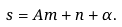Convert formula to latex. <formula><loc_0><loc_0><loc_500><loc_500>s = A m + n + \alpha .</formula> 